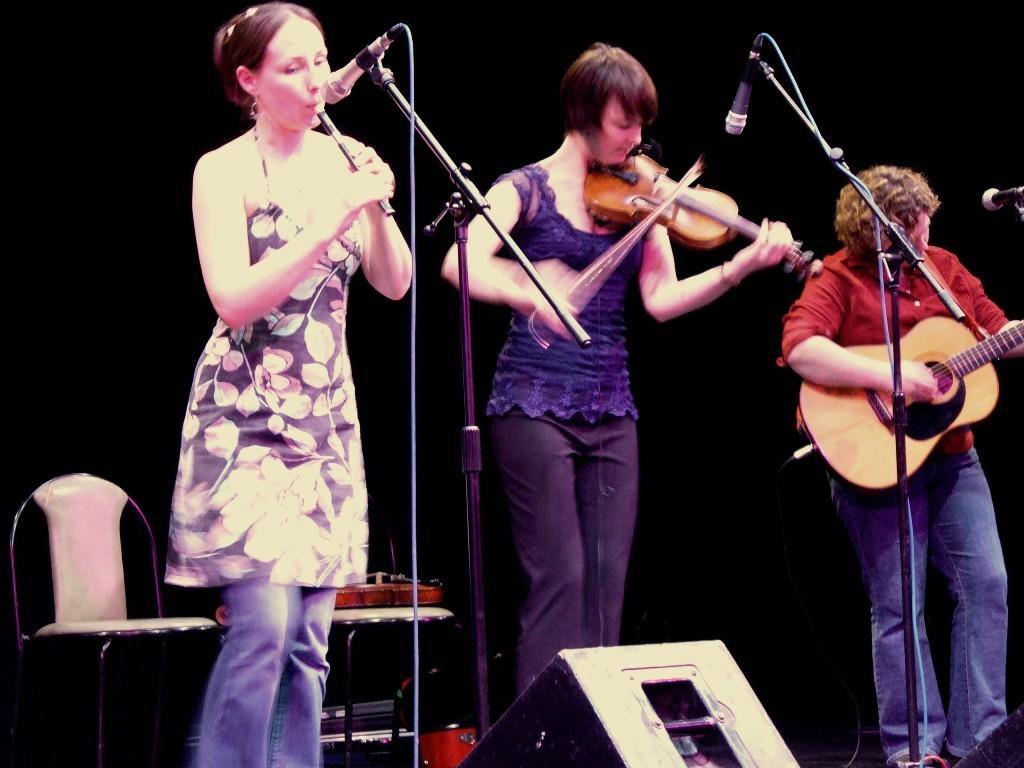Please provide a concise description of this image. In this picture we can see three people, here we can see mics, musical instruments and some objects and in the background we can see it is dark. 